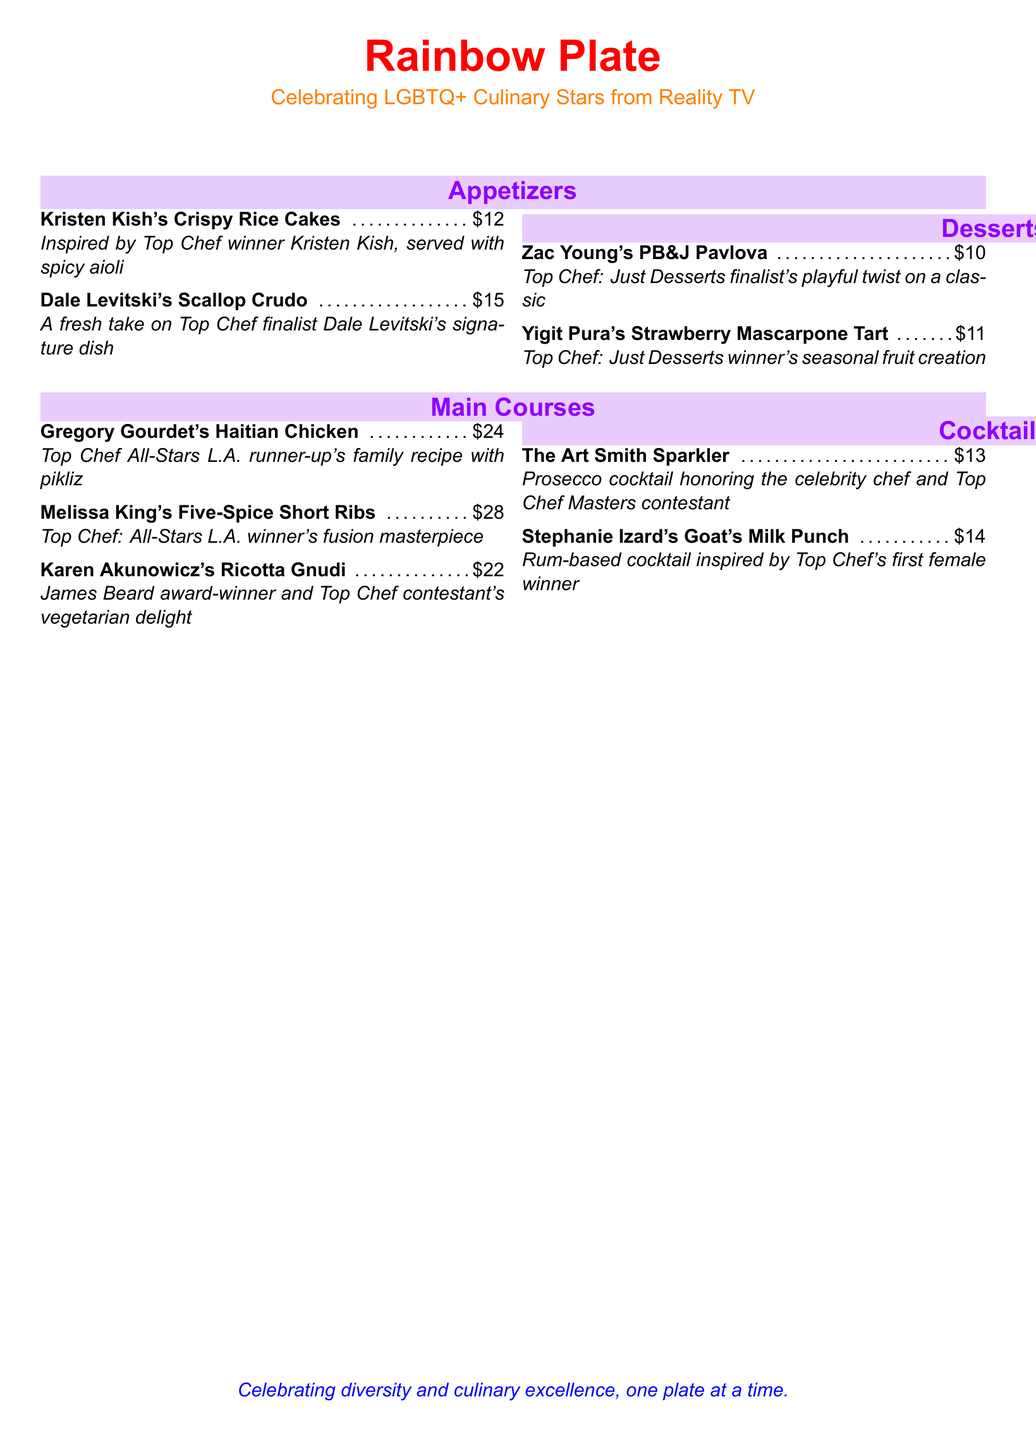What are the appetizers? The appetizers listed in the menu are Kristen Kish's Crispy Rice Cakes and Dale Levitski's Scallop Crudo.
Answer: Kristen Kish's Crispy Rice Cakes, Dale Levitski's Scallop Crudo Who created the PB&J Pavlova? The PB&J Pavlova is created by Zac Young, who is identified as a finalist from Top Chef: Just Desserts.
Answer: Zac Young What is the price of the Goat's Milk Punch? The price of Stephanie Izard's Goat's Milk Punch is mentioned in the menu.
Answer: $14 Which chef is associated with the dessert featuring strawberries? Yigit Pura is associated with the Strawberry Mascarpone Tart, which is detailed in the menu.
Answer: Yigit Pura How many main course dishes are listed? There are three main course dishes listed in the menu based on the main courses section.
Answer: 3 What is the main ingredient in Gregory Gourdet's dish? The dish Gregory Gourdet's Haitian Chicken includes chicken as a primary ingredient.
Answer: Chicken Which dish is described as a vegetarian delight? The dish Karen Akunowicz's Ricotta Gnudi is described as a vegetarian delight in the menu.
Answer: Ricotta Gnudi What is the total price for the appetizers? The total price for the appetizers can be calculated from the listed prices of both appetizers.
Answer: $27 